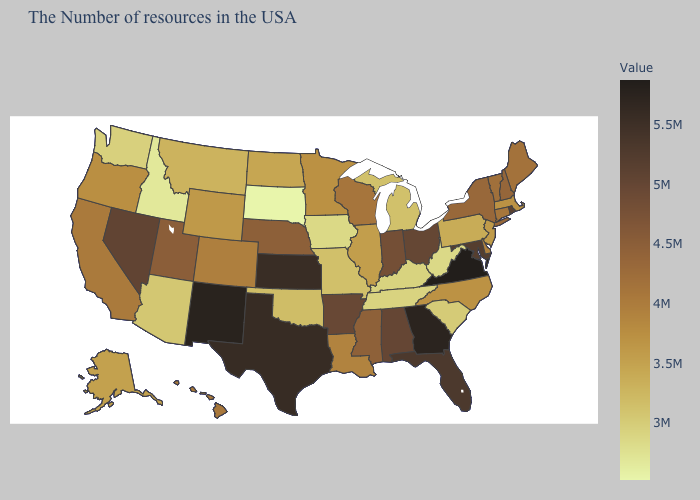Among the states that border New Mexico , does Texas have the highest value?
Quick response, please. Yes. Does the map have missing data?
Be succinct. No. Which states have the lowest value in the USA?
Concise answer only. South Dakota. Does Virginia have the highest value in the USA?
Concise answer only. Yes. 